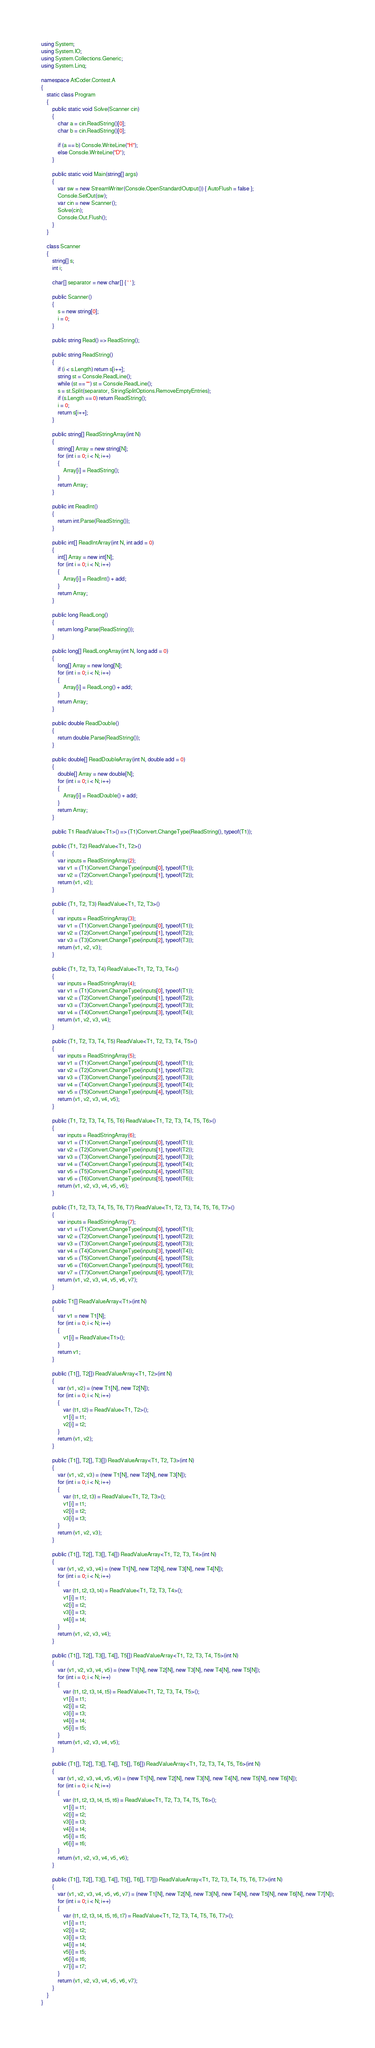Convert code to text. <code><loc_0><loc_0><loc_500><loc_500><_C#_>using System;
using System.IO;
using System.Collections.Generic;
using System.Linq;

namespace AtCoder.Contest.A
{
	static class Program
	{
		public static void Solve(Scanner cin)
		{
			char a = cin.ReadString()[0];
			char b = cin.ReadString()[0];

			if (a == b) Console.WriteLine("H");
			else Console.WriteLine("D");
		}

		public static void Main(string[] args)
		{
			var sw = new StreamWriter(Console.OpenStandardOutput()) { AutoFlush = false };
			Console.SetOut(sw);
			var cin = new Scanner();
			Solve(cin);
			Console.Out.Flush();
		}
	}

	class Scanner
	{
		string[] s;
		int i;

		char[] separator = new char[] { ' ' };

		public Scanner()
		{
			s = new string[0];
			i = 0;
		}

		public string Read() => ReadString();

		public string ReadString()
		{
			if (i < s.Length) return s[i++];
			string st = Console.ReadLine();
			while (st == "") st = Console.ReadLine();
			s = st.Split(separator, StringSplitOptions.RemoveEmptyEntries);
			if (s.Length == 0) return ReadString();
			i = 0;
			return s[i++];
		}

		public string[] ReadStringArray(int N)
		{
			string[] Array = new string[N];
			for (int i = 0; i < N; i++)
			{
				Array[i] = ReadString();
			}
			return Array;
		}

		public int ReadInt()
		{
			return int.Parse(ReadString());
		}

		public int[] ReadIntArray(int N, int add = 0)
		{
			int[] Array = new int[N];
			for (int i = 0; i < N; i++)
			{
				Array[i] = ReadInt() + add;
			}
			return Array;
		}

		public long ReadLong()
		{
			return long.Parse(ReadString());
		}

		public long[] ReadLongArray(int N, long add = 0)
		{
			long[] Array = new long[N];
			for (int i = 0; i < N; i++)
			{
				Array[i] = ReadLong() + add;
			}
			return Array;
		}

		public double ReadDouble()
		{
			return double.Parse(ReadString());
		}

		public double[] ReadDoubleArray(int N, double add = 0)
		{
			double[] Array = new double[N];
			for (int i = 0; i < N; i++)
			{
				Array[i] = ReadDouble() + add;
			}
			return Array;
		}

		public T1 ReadValue<T1>() => (T1)Convert.ChangeType(ReadString(), typeof(T1));

		public (T1, T2) ReadValue<T1, T2>()
		{
			var inputs = ReadStringArray(2);
			var v1 = (T1)Convert.ChangeType(inputs[0], typeof(T1));
			var v2 = (T2)Convert.ChangeType(inputs[1], typeof(T2));
			return (v1, v2);
		}

		public (T1, T2, T3) ReadValue<T1, T2, T3>()
		{
			var inputs = ReadStringArray(3);
			var v1 = (T1)Convert.ChangeType(inputs[0], typeof(T1));
			var v2 = (T2)Convert.ChangeType(inputs[1], typeof(T2));
			var v3 = (T3)Convert.ChangeType(inputs[2], typeof(T3));
			return (v1, v2, v3);
		}

		public (T1, T2, T3, T4) ReadValue<T1, T2, T3, T4>()
		{
			var inputs = ReadStringArray(4);
			var v1 = (T1)Convert.ChangeType(inputs[0], typeof(T1));
			var v2 = (T2)Convert.ChangeType(inputs[1], typeof(T2));
			var v3 = (T3)Convert.ChangeType(inputs[2], typeof(T3));
			var v4 = (T4)Convert.ChangeType(inputs[3], typeof(T4));
			return (v1, v2, v3, v4);
		}

		public (T1, T2, T3, T4, T5) ReadValue<T1, T2, T3, T4, T5>()
		{
			var inputs = ReadStringArray(5);
			var v1 = (T1)Convert.ChangeType(inputs[0], typeof(T1));
			var v2 = (T2)Convert.ChangeType(inputs[1], typeof(T2));
			var v3 = (T3)Convert.ChangeType(inputs[2], typeof(T3));
			var v4 = (T4)Convert.ChangeType(inputs[3], typeof(T4));
			var v5 = (T5)Convert.ChangeType(inputs[4], typeof(T5));
			return (v1, v2, v3, v4, v5);
		}

		public (T1, T2, T3, T4, T5, T6) ReadValue<T1, T2, T3, T4, T5, T6>()
		{
			var inputs = ReadStringArray(6);
			var v1 = (T1)Convert.ChangeType(inputs[0], typeof(T1));
			var v2 = (T2)Convert.ChangeType(inputs[1], typeof(T2));
			var v3 = (T3)Convert.ChangeType(inputs[2], typeof(T3));
			var v4 = (T4)Convert.ChangeType(inputs[3], typeof(T4));
			var v5 = (T5)Convert.ChangeType(inputs[4], typeof(T5));
			var v6 = (T6)Convert.ChangeType(inputs[5], typeof(T6));
			return (v1, v2, v3, v4, v5, v6);
		}

		public (T1, T2, T3, T4, T5, T6, T7) ReadValue<T1, T2, T3, T4, T5, T6, T7>()
		{
			var inputs = ReadStringArray(7);
			var v1 = (T1)Convert.ChangeType(inputs[0], typeof(T1));
			var v2 = (T2)Convert.ChangeType(inputs[1], typeof(T2));
			var v3 = (T3)Convert.ChangeType(inputs[2], typeof(T3));
			var v4 = (T4)Convert.ChangeType(inputs[3], typeof(T4));
			var v5 = (T5)Convert.ChangeType(inputs[4], typeof(T5));
			var v6 = (T6)Convert.ChangeType(inputs[5], typeof(T6));
			var v7 = (T7)Convert.ChangeType(inputs[6], typeof(T7));
			return (v1, v2, v3, v4, v5, v6, v7);
		}

		public T1[] ReadValueArray<T1>(int N)
		{
			var v1 = new T1[N];
			for (int i = 0; i < N; i++)
			{
				v1[i] = ReadValue<T1>();
			}
			return v1;
		}

		public (T1[], T2[]) ReadValueArray<T1, T2>(int N)
		{
			var (v1, v2) = (new T1[N], new T2[N]);
			for (int i = 0; i < N; i++)
			{
				var (t1, t2) = ReadValue<T1, T2>();
				v1[i] = t1;
				v2[i] = t2;
			}
			return (v1, v2);
		}

		public (T1[], T2[], T3[]) ReadValueArray<T1, T2, T3>(int N)
		{
			var (v1, v2, v3) = (new T1[N], new T2[N], new T3[N]);
			for (int i = 0; i < N; i++)
			{
				var (t1, t2, t3) = ReadValue<T1, T2, T3>();
				v1[i] = t1;
				v2[i] = t2;
				v3[i] = t3;
			}
			return (v1, v2, v3);
		}

		public (T1[], T2[], T3[], T4[]) ReadValueArray<T1, T2, T3, T4>(int N)
		{
			var (v1, v2, v3, v4) = (new T1[N], new T2[N], new T3[N], new T4[N]);
			for (int i = 0; i < N; i++)
			{
				var (t1, t2, t3, t4) = ReadValue<T1, T2, T3, T4>();
				v1[i] = t1;
				v2[i] = t2;
				v3[i] = t3;
				v4[i] = t4;
			}
			return (v1, v2, v3, v4);
		}

		public (T1[], T2[], T3[], T4[], T5[]) ReadValueArray<T1, T2, T3, T4, T5>(int N)
		{
			var (v1, v2, v3, v4, v5) = (new T1[N], new T2[N], new T3[N], new T4[N], new T5[N]);
			for (int i = 0; i < N; i++)
			{
				var (t1, t2, t3, t4, t5) = ReadValue<T1, T2, T3, T4, T5>();
				v1[i] = t1;
				v2[i] = t2;
				v3[i] = t3;
				v4[i] = t4;
				v5[i] = t5;
			}
			return (v1, v2, v3, v4, v5);
		}

		public (T1[], T2[], T3[], T4[], T5[], T6[]) ReadValueArray<T1, T2, T3, T4, T5, T6>(int N)
		{
			var (v1, v2, v3, v4, v5, v6) = (new T1[N], new T2[N], new T3[N], new T4[N], new T5[N], new T6[N]);
			for (int i = 0; i < N; i++)
			{
				var (t1, t2, t3, t4, t5, t6) = ReadValue<T1, T2, T3, T4, T5, T6>();
				v1[i] = t1;
				v2[i] = t2;
				v3[i] = t3;
				v4[i] = t4;
				v5[i] = t5;
				v6[i] = t6;
			}
			return (v1, v2, v3, v4, v5, v6);
		}

		public (T1[], T2[], T3[], T4[], T5[], T6[], T7[]) ReadValueArray<T1, T2, T3, T4, T5, T6, T7>(int N)
		{
			var (v1, v2, v3, v4, v5, v6, v7) = (new T1[N], new T2[N], new T3[N], new T4[N], new T5[N], new T6[N], new T7[N]);
			for (int i = 0; i < N; i++)
			{
				var (t1, t2, t3, t4, t5, t6, t7) = ReadValue<T1, T2, T3, T4, T5, T6, T7>();
				v1[i] = t1;
				v2[i] = t2;
				v3[i] = t3;
				v4[i] = t4;
				v5[i] = t5;
				v6[i] = t6;
				v7[i] = t7;
			}
			return (v1, v2, v3, v4, v5, v6, v7);
		}
	}
}
</code> 